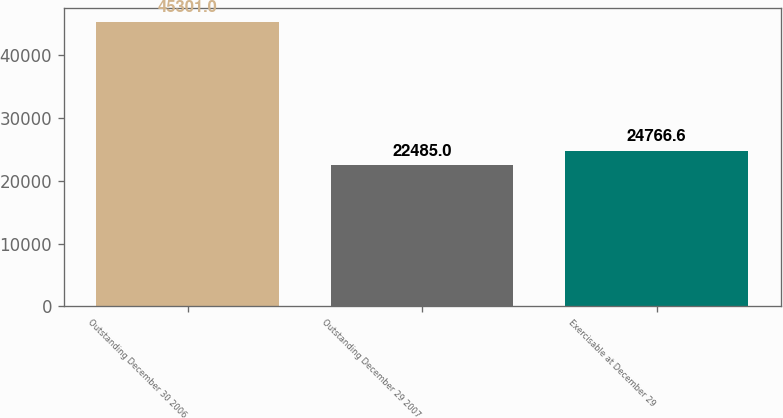<chart> <loc_0><loc_0><loc_500><loc_500><bar_chart><fcel>Outstanding December 30 2006<fcel>Outstanding December 29 2007<fcel>Exercisable at December 29<nl><fcel>45301<fcel>22485<fcel>24766.6<nl></chart> 